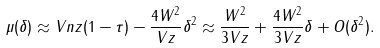Convert formula to latex. <formula><loc_0><loc_0><loc_500><loc_500>\mu ( \delta ) \approx V n z ( 1 - \tau ) - \frac { 4 W ^ { 2 } } { V z } \delta ^ { 2 } \approx \frac { W ^ { 2 } } { 3 V z } + \frac { 4 W ^ { 2 } } { 3 V z } \delta + O ( \delta ^ { 2 } ) .</formula> 